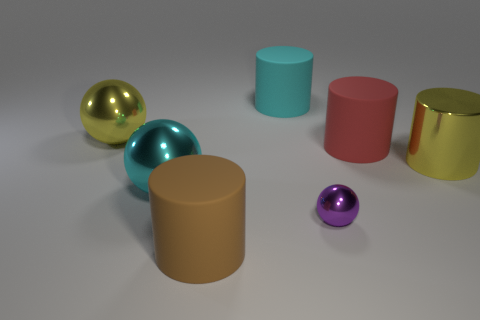How many cubes are either big brown matte things or big yellow objects?
Offer a very short reply. 0. Is the number of big cyan metallic balls on the left side of the tiny purple ball greater than the number of purple shiny balls on the left side of the large brown cylinder?
Your answer should be very brief. Yes. How many yellow metallic cylinders are in front of the large yellow thing right of the purple metal ball?
Keep it short and to the point. 0. How many objects are rubber objects or big red things?
Offer a very short reply. 3. Is the shape of the large red rubber object the same as the big cyan matte thing?
Offer a very short reply. Yes. What is the purple sphere made of?
Provide a succinct answer. Metal. How many shiny balls are both in front of the cyan metal sphere and on the left side of the big brown rubber cylinder?
Your response must be concise. 0. Do the brown rubber object and the red rubber object have the same size?
Ensure brevity in your answer.  Yes. There is a cyan thing that is left of the brown object; is its size the same as the large cyan rubber cylinder?
Your answer should be very brief. Yes. There is a metal sphere on the right side of the brown rubber object; what color is it?
Provide a short and direct response. Purple. 